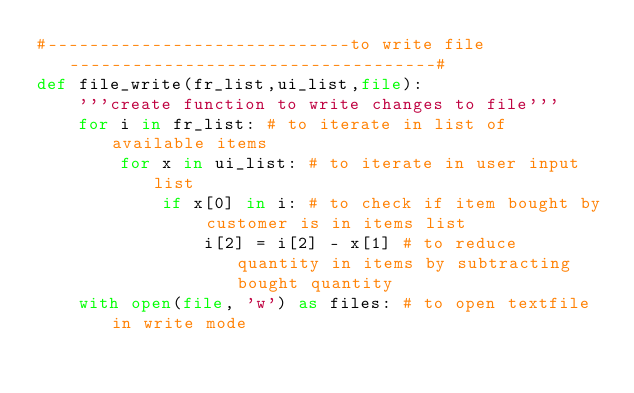Convert code to text. <code><loc_0><loc_0><loc_500><loc_500><_Python_>#-----------------------------to write file-----------------------------------#
def file_write(fr_list,ui_list,file):
    '''create function to write changes to file'''
    for i in fr_list: # to iterate in list of available items
        for x in ui_list: # to iterate in user input list
            if x[0] in i: # to check if item bought by customer is in items list
                i[2] = i[2] - x[1] # to reduce quantity in items by subtracting bought quantity
    with open(file, 'w') as files: # to open textfile in write mode</code> 